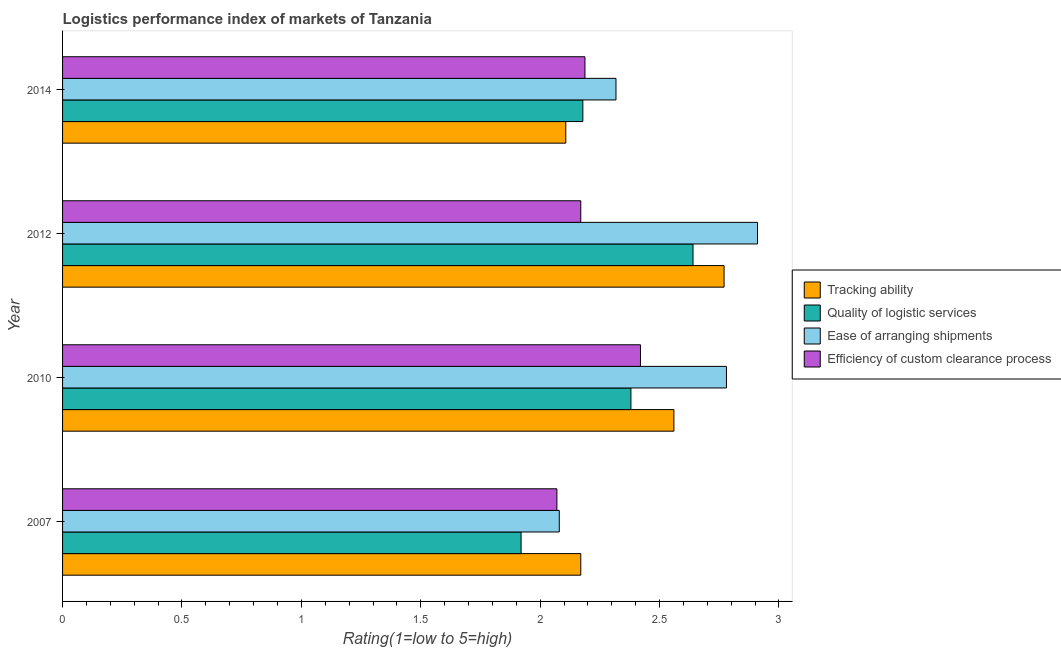How many groups of bars are there?
Provide a succinct answer. 4. Are the number of bars per tick equal to the number of legend labels?
Make the answer very short. Yes. What is the label of the 4th group of bars from the top?
Your answer should be very brief. 2007. What is the lpi rating of quality of logistic services in 2007?
Provide a short and direct response. 1.92. Across all years, what is the maximum lpi rating of efficiency of custom clearance process?
Provide a succinct answer. 2.42. Across all years, what is the minimum lpi rating of tracking ability?
Your answer should be very brief. 2.11. In which year was the lpi rating of quality of logistic services maximum?
Your answer should be very brief. 2012. In which year was the lpi rating of efficiency of custom clearance process minimum?
Provide a succinct answer. 2007. What is the total lpi rating of ease of arranging shipments in the graph?
Your response must be concise. 10.09. What is the difference between the lpi rating of efficiency of custom clearance process in 2007 and that in 2010?
Offer a very short reply. -0.35. What is the difference between the lpi rating of efficiency of custom clearance process in 2012 and the lpi rating of quality of logistic services in 2010?
Provide a succinct answer. -0.21. What is the average lpi rating of efficiency of custom clearance process per year?
Keep it short and to the point. 2.21. In the year 2007, what is the difference between the lpi rating of ease of arranging shipments and lpi rating of efficiency of custom clearance process?
Provide a short and direct response. 0.01. What is the ratio of the lpi rating of efficiency of custom clearance process in 2007 to that in 2010?
Make the answer very short. 0.85. Is the difference between the lpi rating of quality of logistic services in 2010 and 2014 greater than the difference between the lpi rating of ease of arranging shipments in 2010 and 2014?
Give a very brief answer. No. What is the difference between the highest and the second highest lpi rating of ease of arranging shipments?
Your response must be concise. 0.13. What is the difference between the highest and the lowest lpi rating of quality of logistic services?
Give a very brief answer. 0.72. In how many years, is the lpi rating of quality of logistic services greater than the average lpi rating of quality of logistic services taken over all years?
Provide a short and direct response. 2. What does the 1st bar from the top in 2012 represents?
Offer a terse response. Efficiency of custom clearance process. What does the 2nd bar from the bottom in 2014 represents?
Your answer should be very brief. Quality of logistic services. Is it the case that in every year, the sum of the lpi rating of tracking ability and lpi rating of quality of logistic services is greater than the lpi rating of ease of arranging shipments?
Provide a short and direct response. Yes. Are all the bars in the graph horizontal?
Your response must be concise. Yes. How many legend labels are there?
Ensure brevity in your answer.  4. How are the legend labels stacked?
Offer a very short reply. Vertical. What is the title of the graph?
Give a very brief answer. Logistics performance index of markets of Tanzania. What is the label or title of the X-axis?
Your response must be concise. Rating(1=low to 5=high). What is the Rating(1=low to 5=high) in Tracking ability in 2007?
Offer a very short reply. 2.17. What is the Rating(1=low to 5=high) in Quality of logistic services in 2007?
Your answer should be compact. 1.92. What is the Rating(1=low to 5=high) of Ease of arranging shipments in 2007?
Ensure brevity in your answer.  2.08. What is the Rating(1=low to 5=high) of Efficiency of custom clearance process in 2007?
Ensure brevity in your answer.  2.07. What is the Rating(1=low to 5=high) in Tracking ability in 2010?
Offer a very short reply. 2.56. What is the Rating(1=low to 5=high) of Quality of logistic services in 2010?
Offer a very short reply. 2.38. What is the Rating(1=low to 5=high) of Ease of arranging shipments in 2010?
Your answer should be very brief. 2.78. What is the Rating(1=low to 5=high) in Efficiency of custom clearance process in 2010?
Your response must be concise. 2.42. What is the Rating(1=low to 5=high) of Tracking ability in 2012?
Offer a terse response. 2.77. What is the Rating(1=low to 5=high) in Quality of logistic services in 2012?
Make the answer very short. 2.64. What is the Rating(1=low to 5=high) of Ease of arranging shipments in 2012?
Your answer should be compact. 2.91. What is the Rating(1=low to 5=high) in Efficiency of custom clearance process in 2012?
Your answer should be compact. 2.17. What is the Rating(1=low to 5=high) of Tracking ability in 2014?
Keep it short and to the point. 2.11. What is the Rating(1=low to 5=high) in Quality of logistic services in 2014?
Offer a terse response. 2.18. What is the Rating(1=low to 5=high) of Ease of arranging shipments in 2014?
Your answer should be very brief. 2.32. What is the Rating(1=low to 5=high) of Efficiency of custom clearance process in 2014?
Your answer should be compact. 2.19. Across all years, what is the maximum Rating(1=low to 5=high) in Tracking ability?
Provide a succinct answer. 2.77. Across all years, what is the maximum Rating(1=low to 5=high) of Quality of logistic services?
Ensure brevity in your answer.  2.64. Across all years, what is the maximum Rating(1=low to 5=high) of Ease of arranging shipments?
Your answer should be very brief. 2.91. Across all years, what is the maximum Rating(1=low to 5=high) of Efficiency of custom clearance process?
Provide a short and direct response. 2.42. Across all years, what is the minimum Rating(1=low to 5=high) of Tracking ability?
Provide a short and direct response. 2.11. Across all years, what is the minimum Rating(1=low to 5=high) in Quality of logistic services?
Provide a short and direct response. 1.92. Across all years, what is the minimum Rating(1=low to 5=high) of Ease of arranging shipments?
Your answer should be compact. 2.08. Across all years, what is the minimum Rating(1=low to 5=high) in Efficiency of custom clearance process?
Offer a very short reply. 2.07. What is the total Rating(1=low to 5=high) of Tracking ability in the graph?
Provide a succinct answer. 9.61. What is the total Rating(1=low to 5=high) of Quality of logistic services in the graph?
Provide a succinct answer. 9.12. What is the total Rating(1=low to 5=high) in Ease of arranging shipments in the graph?
Your answer should be very brief. 10.09. What is the total Rating(1=low to 5=high) in Efficiency of custom clearance process in the graph?
Your answer should be compact. 8.85. What is the difference between the Rating(1=low to 5=high) in Tracking ability in 2007 and that in 2010?
Ensure brevity in your answer.  -0.39. What is the difference between the Rating(1=low to 5=high) in Quality of logistic services in 2007 and that in 2010?
Your answer should be compact. -0.46. What is the difference between the Rating(1=low to 5=high) in Efficiency of custom clearance process in 2007 and that in 2010?
Offer a terse response. -0.35. What is the difference between the Rating(1=low to 5=high) of Tracking ability in 2007 and that in 2012?
Offer a very short reply. -0.6. What is the difference between the Rating(1=low to 5=high) in Quality of logistic services in 2007 and that in 2012?
Offer a terse response. -0.72. What is the difference between the Rating(1=low to 5=high) in Ease of arranging shipments in 2007 and that in 2012?
Provide a succinct answer. -0.83. What is the difference between the Rating(1=low to 5=high) of Tracking ability in 2007 and that in 2014?
Provide a succinct answer. 0.06. What is the difference between the Rating(1=low to 5=high) in Quality of logistic services in 2007 and that in 2014?
Your answer should be very brief. -0.26. What is the difference between the Rating(1=low to 5=high) of Ease of arranging shipments in 2007 and that in 2014?
Ensure brevity in your answer.  -0.24. What is the difference between the Rating(1=low to 5=high) in Efficiency of custom clearance process in 2007 and that in 2014?
Offer a terse response. -0.12. What is the difference between the Rating(1=low to 5=high) in Tracking ability in 2010 and that in 2012?
Provide a short and direct response. -0.21. What is the difference between the Rating(1=low to 5=high) of Quality of logistic services in 2010 and that in 2012?
Offer a terse response. -0.26. What is the difference between the Rating(1=low to 5=high) of Ease of arranging shipments in 2010 and that in 2012?
Provide a short and direct response. -0.13. What is the difference between the Rating(1=low to 5=high) in Efficiency of custom clearance process in 2010 and that in 2012?
Give a very brief answer. 0.25. What is the difference between the Rating(1=low to 5=high) of Tracking ability in 2010 and that in 2014?
Offer a very short reply. 0.45. What is the difference between the Rating(1=low to 5=high) of Quality of logistic services in 2010 and that in 2014?
Provide a short and direct response. 0.2. What is the difference between the Rating(1=low to 5=high) in Ease of arranging shipments in 2010 and that in 2014?
Your answer should be compact. 0.46. What is the difference between the Rating(1=low to 5=high) of Efficiency of custom clearance process in 2010 and that in 2014?
Ensure brevity in your answer.  0.23. What is the difference between the Rating(1=low to 5=high) of Tracking ability in 2012 and that in 2014?
Provide a succinct answer. 0.66. What is the difference between the Rating(1=low to 5=high) in Quality of logistic services in 2012 and that in 2014?
Your answer should be very brief. 0.46. What is the difference between the Rating(1=low to 5=high) in Ease of arranging shipments in 2012 and that in 2014?
Give a very brief answer. 0.59. What is the difference between the Rating(1=low to 5=high) in Efficiency of custom clearance process in 2012 and that in 2014?
Your answer should be very brief. -0.02. What is the difference between the Rating(1=low to 5=high) of Tracking ability in 2007 and the Rating(1=low to 5=high) of Quality of logistic services in 2010?
Ensure brevity in your answer.  -0.21. What is the difference between the Rating(1=low to 5=high) of Tracking ability in 2007 and the Rating(1=low to 5=high) of Ease of arranging shipments in 2010?
Provide a short and direct response. -0.61. What is the difference between the Rating(1=low to 5=high) in Quality of logistic services in 2007 and the Rating(1=low to 5=high) in Ease of arranging shipments in 2010?
Provide a short and direct response. -0.86. What is the difference between the Rating(1=low to 5=high) of Ease of arranging shipments in 2007 and the Rating(1=low to 5=high) of Efficiency of custom clearance process in 2010?
Provide a succinct answer. -0.34. What is the difference between the Rating(1=low to 5=high) in Tracking ability in 2007 and the Rating(1=low to 5=high) in Quality of logistic services in 2012?
Your answer should be very brief. -0.47. What is the difference between the Rating(1=low to 5=high) in Tracking ability in 2007 and the Rating(1=low to 5=high) in Ease of arranging shipments in 2012?
Keep it short and to the point. -0.74. What is the difference between the Rating(1=low to 5=high) in Tracking ability in 2007 and the Rating(1=low to 5=high) in Efficiency of custom clearance process in 2012?
Provide a short and direct response. 0. What is the difference between the Rating(1=low to 5=high) in Quality of logistic services in 2007 and the Rating(1=low to 5=high) in Ease of arranging shipments in 2012?
Offer a very short reply. -0.99. What is the difference between the Rating(1=low to 5=high) of Quality of logistic services in 2007 and the Rating(1=low to 5=high) of Efficiency of custom clearance process in 2012?
Your answer should be very brief. -0.25. What is the difference between the Rating(1=low to 5=high) of Ease of arranging shipments in 2007 and the Rating(1=low to 5=high) of Efficiency of custom clearance process in 2012?
Your response must be concise. -0.09. What is the difference between the Rating(1=low to 5=high) in Tracking ability in 2007 and the Rating(1=low to 5=high) in Quality of logistic services in 2014?
Offer a terse response. -0.01. What is the difference between the Rating(1=low to 5=high) in Tracking ability in 2007 and the Rating(1=low to 5=high) in Ease of arranging shipments in 2014?
Offer a terse response. -0.15. What is the difference between the Rating(1=low to 5=high) in Tracking ability in 2007 and the Rating(1=low to 5=high) in Efficiency of custom clearance process in 2014?
Give a very brief answer. -0.02. What is the difference between the Rating(1=low to 5=high) of Quality of logistic services in 2007 and the Rating(1=low to 5=high) of Ease of arranging shipments in 2014?
Your answer should be compact. -0.4. What is the difference between the Rating(1=low to 5=high) in Quality of logistic services in 2007 and the Rating(1=low to 5=high) in Efficiency of custom clearance process in 2014?
Make the answer very short. -0.27. What is the difference between the Rating(1=low to 5=high) in Ease of arranging shipments in 2007 and the Rating(1=low to 5=high) in Efficiency of custom clearance process in 2014?
Offer a terse response. -0.11. What is the difference between the Rating(1=low to 5=high) of Tracking ability in 2010 and the Rating(1=low to 5=high) of Quality of logistic services in 2012?
Your answer should be compact. -0.08. What is the difference between the Rating(1=low to 5=high) in Tracking ability in 2010 and the Rating(1=low to 5=high) in Ease of arranging shipments in 2012?
Keep it short and to the point. -0.35. What is the difference between the Rating(1=low to 5=high) of Tracking ability in 2010 and the Rating(1=low to 5=high) of Efficiency of custom clearance process in 2012?
Provide a succinct answer. 0.39. What is the difference between the Rating(1=low to 5=high) in Quality of logistic services in 2010 and the Rating(1=low to 5=high) in Ease of arranging shipments in 2012?
Provide a short and direct response. -0.53. What is the difference between the Rating(1=low to 5=high) of Quality of logistic services in 2010 and the Rating(1=low to 5=high) of Efficiency of custom clearance process in 2012?
Provide a short and direct response. 0.21. What is the difference between the Rating(1=low to 5=high) of Ease of arranging shipments in 2010 and the Rating(1=low to 5=high) of Efficiency of custom clearance process in 2012?
Provide a succinct answer. 0.61. What is the difference between the Rating(1=low to 5=high) in Tracking ability in 2010 and the Rating(1=low to 5=high) in Quality of logistic services in 2014?
Give a very brief answer. 0.38. What is the difference between the Rating(1=low to 5=high) of Tracking ability in 2010 and the Rating(1=low to 5=high) of Ease of arranging shipments in 2014?
Give a very brief answer. 0.24. What is the difference between the Rating(1=low to 5=high) of Tracking ability in 2010 and the Rating(1=low to 5=high) of Efficiency of custom clearance process in 2014?
Make the answer very short. 0.37. What is the difference between the Rating(1=low to 5=high) of Quality of logistic services in 2010 and the Rating(1=low to 5=high) of Ease of arranging shipments in 2014?
Your answer should be compact. 0.06. What is the difference between the Rating(1=low to 5=high) of Quality of logistic services in 2010 and the Rating(1=low to 5=high) of Efficiency of custom clearance process in 2014?
Keep it short and to the point. 0.19. What is the difference between the Rating(1=low to 5=high) in Ease of arranging shipments in 2010 and the Rating(1=low to 5=high) in Efficiency of custom clearance process in 2014?
Keep it short and to the point. 0.59. What is the difference between the Rating(1=low to 5=high) of Tracking ability in 2012 and the Rating(1=low to 5=high) of Quality of logistic services in 2014?
Offer a very short reply. 0.59. What is the difference between the Rating(1=low to 5=high) in Tracking ability in 2012 and the Rating(1=low to 5=high) in Ease of arranging shipments in 2014?
Provide a short and direct response. 0.45. What is the difference between the Rating(1=low to 5=high) in Tracking ability in 2012 and the Rating(1=low to 5=high) in Efficiency of custom clearance process in 2014?
Keep it short and to the point. 0.58. What is the difference between the Rating(1=low to 5=high) of Quality of logistic services in 2012 and the Rating(1=low to 5=high) of Ease of arranging shipments in 2014?
Offer a very short reply. 0.32. What is the difference between the Rating(1=low to 5=high) of Quality of logistic services in 2012 and the Rating(1=low to 5=high) of Efficiency of custom clearance process in 2014?
Your answer should be compact. 0.45. What is the difference between the Rating(1=low to 5=high) of Ease of arranging shipments in 2012 and the Rating(1=low to 5=high) of Efficiency of custom clearance process in 2014?
Provide a succinct answer. 0.72. What is the average Rating(1=low to 5=high) in Tracking ability per year?
Your answer should be very brief. 2.4. What is the average Rating(1=low to 5=high) in Quality of logistic services per year?
Offer a very short reply. 2.28. What is the average Rating(1=low to 5=high) in Ease of arranging shipments per year?
Offer a very short reply. 2.52. What is the average Rating(1=low to 5=high) in Efficiency of custom clearance process per year?
Your answer should be very brief. 2.21. In the year 2007, what is the difference between the Rating(1=low to 5=high) of Tracking ability and Rating(1=low to 5=high) of Ease of arranging shipments?
Offer a very short reply. 0.09. In the year 2007, what is the difference between the Rating(1=low to 5=high) in Quality of logistic services and Rating(1=low to 5=high) in Ease of arranging shipments?
Your answer should be compact. -0.16. In the year 2007, what is the difference between the Rating(1=low to 5=high) of Ease of arranging shipments and Rating(1=low to 5=high) of Efficiency of custom clearance process?
Your answer should be compact. 0.01. In the year 2010, what is the difference between the Rating(1=low to 5=high) in Tracking ability and Rating(1=low to 5=high) in Quality of logistic services?
Your answer should be compact. 0.18. In the year 2010, what is the difference between the Rating(1=low to 5=high) in Tracking ability and Rating(1=low to 5=high) in Ease of arranging shipments?
Offer a terse response. -0.22. In the year 2010, what is the difference between the Rating(1=low to 5=high) in Tracking ability and Rating(1=low to 5=high) in Efficiency of custom clearance process?
Keep it short and to the point. 0.14. In the year 2010, what is the difference between the Rating(1=low to 5=high) in Quality of logistic services and Rating(1=low to 5=high) in Ease of arranging shipments?
Your answer should be very brief. -0.4. In the year 2010, what is the difference between the Rating(1=low to 5=high) in Quality of logistic services and Rating(1=low to 5=high) in Efficiency of custom clearance process?
Provide a short and direct response. -0.04. In the year 2010, what is the difference between the Rating(1=low to 5=high) of Ease of arranging shipments and Rating(1=low to 5=high) of Efficiency of custom clearance process?
Make the answer very short. 0.36. In the year 2012, what is the difference between the Rating(1=low to 5=high) of Tracking ability and Rating(1=low to 5=high) of Quality of logistic services?
Your response must be concise. 0.13. In the year 2012, what is the difference between the Rating(1=low to 5=high) in Tracking ability and Rating(1=low to 5=high) in Ease of arranging shipments?
Provide a succinct answer. -0.14. In the year 2012, what is the difference between the Rating(1=low to 5=high) of Quality of logistic services and Rating(1=low to 5=high) of Ease of arranging shipments?
Your answer should be very brief. -0.27. In the year 2012, what is the difference between the Rating(1=low to 5=high) of Quality of logistic services and Rating(1=low to 5=high) of Efficiency of custom clearance process?
Make the answer very short. 0.47. In the year 2012, what is the difference between the Rating(1=low to 5=high) of Ease of arranging shipments and Rating(1=low to 5=high) of Efficiency of custom clearance process?
Your answer should be very brief. 0.74. In the year 2014, what is the difference between the Rating(1=low to 5=high) of Tracking ability and Rating(1=low to 5=high) of Quality of logistic services?
Your response must be concise. -0.07. In the year 2014, what is the difference between the Rating(1=low to 5=high) in Tracking ability and Rating(1=low to 5=high) in Ease of arranging shipments?
Your answer should be compact. -0.21. In the year 2014, what is the difference between the Rating(1=low to 5=high) of Tracking ability and Rating(1=low to 5=high) of Efficiency of custom clearance process?
Your answer should be very brief. -0.08. In the year 2014, what is the difference between the Rating(1=low to 5=high) in Quality of logistic services and Rating(1=low to 5=high) in Ease of arranging shipments?
Provide a short and direct response. -0.14. In the year 2014, what is the difference between the Rating(1=low to 5=high) of Quality of logistic services and Rating(1=low to 5=high) of Efficiency of custom clearance process?
Offer a terse response. -0.01. In the year 2014, what is the difference between the Rating(1=low to 5=high) of Ease of arranging shipments and Rating(1=low to 5=high) of Efficiency of custom clearance process?
Give a very brief answer. 0.13. What is the ratio of the Rating(1=low to 5=high) in Tracking ability in 2007 to that in 2010?
Provide a succinct answer. 0.85. What is the ratio of the Rating(1=low to 5=high) in Quality of logistic services in 2007 to that in 2010?
Make the answer very short. 0.81. What is the ratio of the Rating(1=low to 5=high) in Ease of arranging shipments in 2007 to that in 2010?
Your response must be concise. 0.75. What is the ratio of the Rating(1=low to 5=high) in Efficiency of custom clearance process in 2007 to that in 2010?
Offer a very short reply. 0.86. What is the ratio of the Rating(1=low to 5=high) in Tracking ability in 2007 to that in 2012?
Give a very brief answer. 0.78. What is the ratio of the Rating(1=low to 5=high) of Quality of logistic services in 2007 to that in 2012?
Provide a succinct answer. 0.73. What is the ratio of the Rating(1=low to 5=high) in Ease of arranging shipments in 2007 to that in 2012?
Ensure brevity in your answer.  0.71. What is the ratio of the Rating(1=low to 5=high) of Efficiency of custom clearance process in 2007 to that in 2012?
Give a very brief answer. 0.95. What is the ratio of the Rating(1=low to 5=high) in Tracking ability in 2007 to that in 2014?
Your answer should be very brief. 1.03. What is the ratio of the Rating(1=low to 5=high) of Quality of logistic services in 2007 to that in 2014?
Offer a very short reply. 0.88. What is the ratio of the Rating(1=low to 5=high) in Ease of arranging shipments in 2007 to that in 2014?
Give a very brief answer. 0.9. What is the ratio of the Rating(1=low to 5=high) in Efficiency of custom clearance process in 2007 to that in 2014?
Keep it short and to the point. 0.95. What is the ratio of the Rating(1=low to 5=high) of Tracking ability in 2010 to that in 2012?
Provide a succinct answer. 0.92. What is the ratio of the Rating(1=low to 5=high) of Quality of logistic services in 2010 to that in 2012?
Provide a succinct answer. 0.9. What is the ratio of the Rating(1=low to 5=high) of Ease of arranging shipments in 2010 to that in 2012?
Offer a terse response. 0.96. What is the ratio of the Rating(1=low to 5=high) in Efficiency of custom clearance process in 2010 to that in 2012?
Provide a succinct answer. 1.12. What is the ratio of the Rating(1=low to 5=high) in Tracking ability in 2010 to that in 2014?
Ensure brevity in your answer.  1.21. What is the ratio of the Rating(1=low to 5=high) of Quality of logistic services in 2010 to that in 2014?
Make the answer very short. 1.09. What is the ratio of the Rating(1=low to 5=high) in Ease of arranging shipments in 2010 to that in 2014?
Give a very brief answer. 1.2. What is the ratio of the Rating(1=low to 5=high) in Efficiency of custom clearance process in 2010 to that in 2014?
Make the answer very short. 1.11. What is the ratio of the Rating(1=low to 5=high) in Tracking ability in 2012 to that in 2014?
Keep it short and to the point. 1.31. What is the ratio of the Rating(1=low to 5=high) of Quality of logistic services in 2012 to that in 2014?
Ensure brevity in your answer.  1.21. What is the ratio of the Rating(1=low to 5=high) in Ease of arranging shipments in 2012 to that in 2014?
Give a very brief answer. 1.26. What is the difference between the highest and the second highest Rating(1=low to 5=high) in Tracking ability?
Ensure brevity in your answer.  0.21. What is the difference between the highest and the second highest Rating(1=low to 5=high) of Quality of logistic services?
Ensure brevity in your answer.  0.26. What is the difference between the highest and the second highest Rating(1=low to 5=high) in Ease of arranging shipments?
Provide a short and direct response. 0.13. What is the difference between the highest and the second highest Rating(1=low to 5=high) in Efficiency of custom clearance process?
Your response must be concise. 0.23. What is the difference between the highest and the lowest Rating(1=low to 5=high) of Tracking ability?
Provide a succinct answer. 0.66. What is the difference between the highest and the lowest Rating(1=low to 5=high) of Quality of logistic services?
Keep it short and to the point. 0.72. What is the difference between the highest and the lowest Rating(1=low to 5=high) in Ease of arranging shipments?
Make the answer very short. 0.83. 